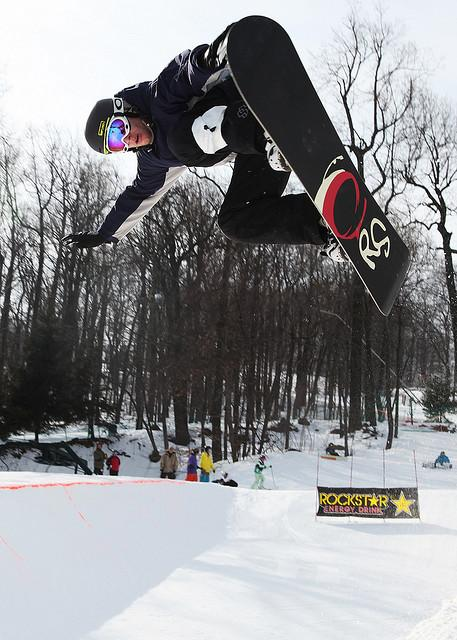How many flavors available in Rock star energy drink? Please explain your reasoning. 20. It's actually more than 30 now. b just happens to be closest. 